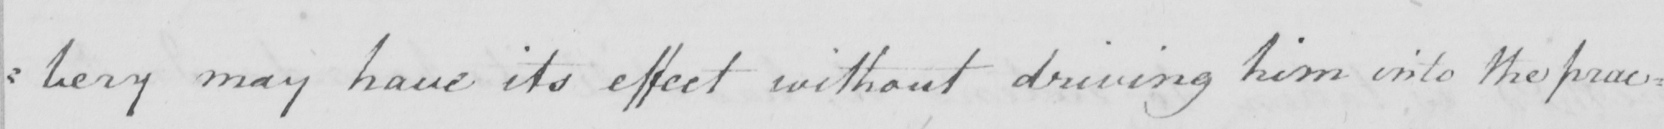What does this handwritten line say? : bery may have its effect without driving him into the prac= 